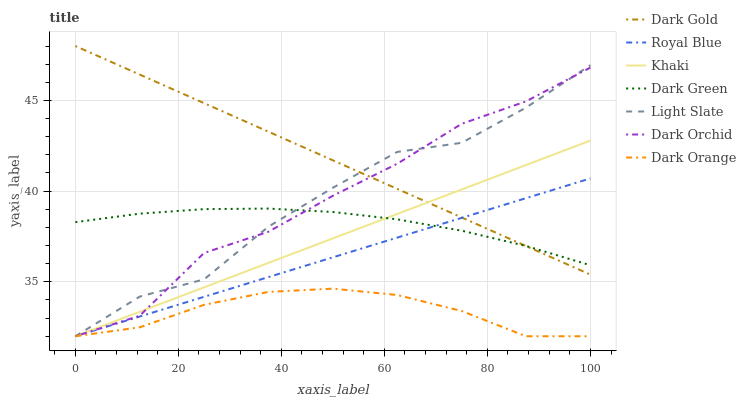Does Dark Orange have the minimum area under the curve?
Answer yes or no. Yes. Does Dark Gold have the maximum area under the curve?
Answer yes or no. Yes. Does Khaki have the minimum area under the curve?
Answer yes or no. No. Does Khaki have the maximum area under the curve?
Answer yes or no. No. Is Khaki the smoothest?
Answer yes or no. Yes. Is Dark Orchid the roughest?
Answer yes or no. Yes. Is Light Slate the smoothest?
Answer yes or no. No. Is Light Slate the roughest?
Answer yes or no. No. Does Dark Orange have the lowest value?
Answer yes or no. Yes. Does Dark Gold have the lowest value?
Answer yes or no. No. Does Dark Gold have the highest value?
Answer yes or no. Yes. Does Khaki have the highest value?
Answer yes or no. No. Is Dark Orange less than Dark Green?
Answer yes or no. Yes. Is Dark Green greater than Dark Orange?
Answer yes or no. Yes. Does Royal Blue intersect Dark Orchid?
Answer yes or no. Yes. Is Royal Blue less than Dark Orchid?
Answer yes or no. No. Is Royal Blue greater than Dark Orchid?
Answer yes or no. No. Does Dark Orange intersect Dark Green?
Answer yes or no. No. 